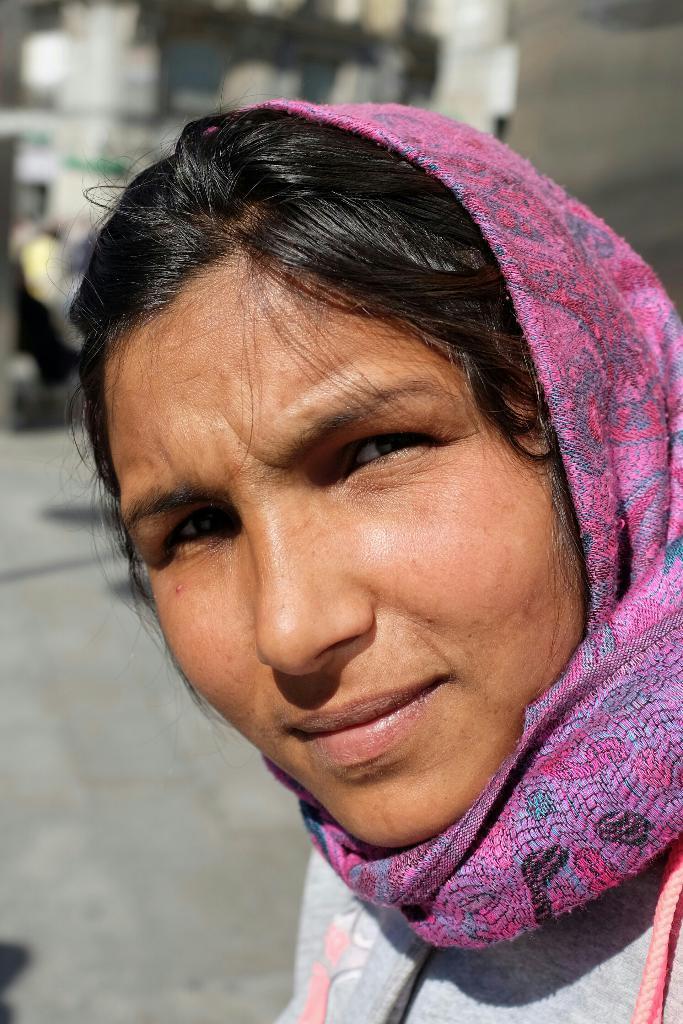Can you describe this image briefly? This image consists of a woman's face. She is wearing a scarf. 